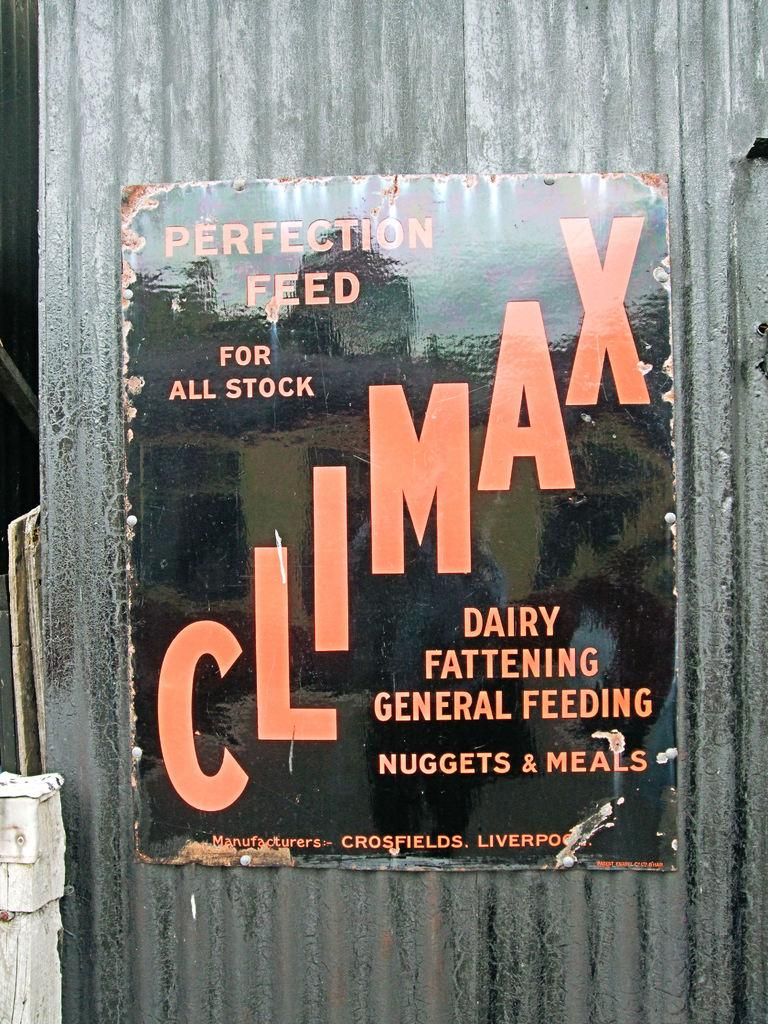<image>
Share a concise interpretation of the image provided. Poster on a wall for Climax which has Nuggets & Meals. 